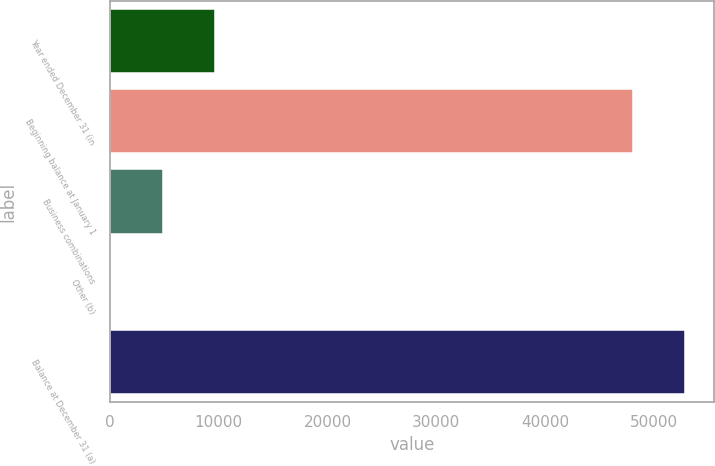Convert chart to OTSL. <chart><loc_0><loc_0><loc_500><loc_500><bar_chart><fcel>Year ended December 31 (in<fcel>Beginning balance at January 1<fcel>Business combinations<fcel>Other (b)<fcel>Balance at December 31 (a)<nl><fcel>9718.6<fcel>48027<fcel>4888.8<fcel>59<fcel>52856.8<nl></chart> 